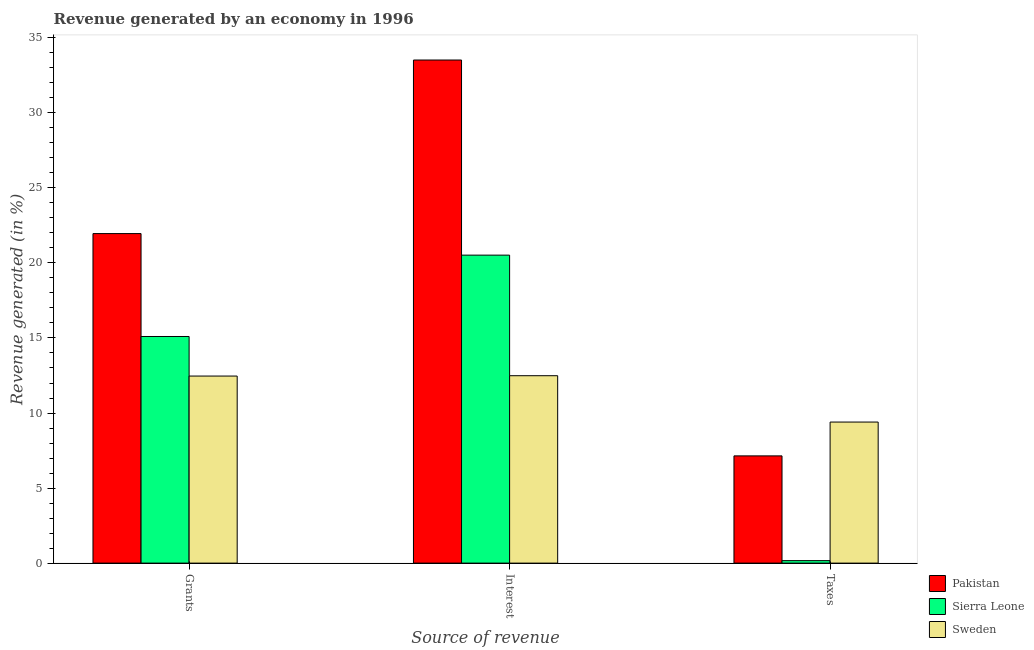How many groups of bars are there?
Your answer should be compact. 3. Are the number of bars on each tick of the X-axis equal?
Offer a very short reply. Yes. How many bars are there on the 1st tick from the left?
Your response must be concise. 3. How many bars are there on the 3rd tick from the right?
Keep it short and to the point. 3. What is the label of the 3rd group of bars from the left?
Your answer should be very brief. Taxes. What is the percentage of revenue generated by interest in Pakistan?
Keep it short and to the point. 33.52. Across all countries, what is the maximum percentage of revenue generated by interest?
Give a very brief answer. 33.52. Across all countries, what is the minimum percentage of revenue generated by interest?
Provide a short and direct response. 12.49. In which country was the percentage of revenue generated by interest minimum?
Your answer should be compact. Sweden. What is the total percentage of revenue generated by grants in the graph?
Your answer should be compact. 49.52. What is the difference between the percentage of revenue generated by grants in Sweden and that in Pakistan?
Your answer should be very brief. -9.49. What is the difference between the percentage of revenue generated by taxes in Sierra Leone and the percentage of revenue generated by interest in Sweden?
Your answer should be very brief. -12.32. What is the average percentage of revenue generated by taxes per country?
Your answer should be very brief. 5.57. What is the difference between the percentage of revenue generated by interest and percentage of revenue generated by grants in Pakistan?
Give a very brief answer. 11.56. In how many countries, is the percentage of revenue generated by taxes greater than 34 %?
Your answer should be very brief. 0. What is the ratio of the percentage of revenue generated by interest in Sierra Leone to that in Pakistan?
Provide a succinct answer. 0.61. What is the difference between the highest and the second highest percentage of revenue generated by taxes?
Make the answer very short. 2.25. What is the difference between the highest and the lowest percentage of revenue generated by interest?
Provide a succinct answer. 21.03. In how many countries, is the percentage of revenue generated by grants greater than the average percentage of revenue generated by grants taken over all countries?
Offer a terse response. 1. Is the sum of the percentage of revenue generated by interest in Sweden and Pakistan greater than the maximum percentage of revenue generated by taxes across all countries?
Give a very brief answer. Yes. What does the 1st bar from the left in Taxes represents?
Provide a succinct answer. Pakistan. Is it the case that in every country, the sum of the percentage of revenue generated by grants and percentage of revenue generated by interest is greater than the percentage of revenue generated by taxes?
Offer a terse response. Yes. How many bars are there?
Make the answer very short. 9. Are all the bars in the graph horizontal?
Your response must be concise. No. How many countries are there in the graph?
Provide a succinct answer. 3. How many legend labels are there?
Offer a very short reply. 3. How are the legend labels stacked?
Provide a short and direct response. Vertical. What is the title of the graph?
Provide a short and direct response. Revenue generated by an economy in 1996. What is the label or title of the X-axis?
Offer a terse response. Source of revenue. What is the label or title of the Y-axis?
Provide a succinct answer. Revenue generated (in %). What is the Revenue generated (in %) in Pakistan in Grants?
Your response must be concise. 21.96. What is the Revenue generated (in %) of Sierra Leone in Grants?
Offer a very short reply. 15.1. What is the Revenue generated (in %) in Sweden in Grants?
Your response must be concise. 12.46. What is the Revenue generated (in %) of Pakistan in Interest?
Offer a terse response. 33.52. What is the Revenue generated (in %) of Sierra Leone in Interest?
Provide a succinct answer. 20.52. What is the Revenue generated (in %) of Sweden in Interest?
Your response must be concise. 12.49. What is the Revenue generated (in %) in Pakistan in Taxes?
Offer a terse response. 7.14. What is the Revenue generated (in %) of Sierra Leone in Taxes?
Provide a succinct answer. 0.16. What is the Revenue generated (in %) in Sweden in Taxes?
Ensure brevity in your answer.  9.4. Across all Source of revenue, what is the maximum Revenue generated (in %) of Pakistan?
Provide a succinct answer. 33.52. Across all Source of revenue, what is the maximum Revenue generated (in %) in Sierra Leone?
Offer a terse response. 20.52. Across all Source of revenue, what is the maximum Revenue generated (in %) of Sweden?
Provide a succinct answer. 12.49. Across all Source of revenue, what is the minimum Revenue generated (in %) of Pakistan?
Keep it short and to the point. 7.14. Across all Source of revenue, what is the minimum Revenue generated (in %) in Sierra Leone?
Give a very brief answer. 0.16. Across all Source of revenue, what is the minimum Revenue generated (in %) of Sweden?
Offer a very short reply. 9.4. What is the total Revenue generated (in %) in Pakistan in the graph?
Your response must be concise. 62.62. What is the total Revenue generated (in %) in Sierra Leone in the graph?
Keep it short and to the point. 35.78. What is the total Revenue generated (in %) of Sweden in the graph?
Ensure brevity in your answer.  34.35. What is the difference between the Revenue generated (in %) in Pakistan in Grants and that in Interest?
Provide a succinct answer. -11.56. What is the difference between the Revenue generated (in %) of Sierra Leone in Grants and that in Interest?
Offer a very short reply. -5.42. What is the difference between the Revenue generated (in %) of Sweden in Grants and that in Interest?
Give a very brief answer. -0.02. What is the difference between the Revenue generated (in %) in Pakistan in Grants and that in Taxes?
Offer a terse response. 14.81. What is the difference between the Revenue generated (in %) in Sierra Leone in Grants and that in Taxes?
Offer a terse response. 14.93. What is the difference between the Revenue generated (in %) in Sweden in Grants and that in Taxes?
Ensure brevity in your answer.  3.06. What is the difference between the Revenue generated (in %) in Pakistan in Interest and that in Taxes?
Make the answer very short. 26.37. What is the difference between the Revenue generated (in %) in Sierra Leone in Interest and that in Taxes?
Your response must be concise. 20.35. What is the difference between the Revenue generated (in %) in Sweden in Interest and that in Taxes?
Your answer should be very brief. 3.09. What is the difference between the Revenue generated (in %) of Pakistan in Grants and the Revenue generated (in %) of Sierra Leone in Interest?
Give a very brief answer. 1.44. What is the difference between the Revenue generated (in %) in Pakistan in Grants and the Revenue generated (in %) in Sweden in Interest?
Make the answer very short. 9.47. What is the difference between the Revenue generated (in %) in Sierra Leone in Grants and the Revenue generated (in %) in Sweden in Interest?
Your answer should be very brief. 2.61. What is the difference between the Revenue generated (in %) of Pakistan in Grants and the Revenue generated (in %) of Sierra Leone in Taxes?
Offer a very short reply. 21.79. What is the difference between the Revenue generated (in %) in Pakistan in Grants and the Revenue generated (in %) in Sweden in Taxes?
Your answer should be compact. 12.56. What is the difference between the Revenue generated (in %) of Sierra Leone in Grants and the Revenue generated (in %) of Sweden in Taxes?
Offer a terse response. 5.7. What is the difference between the Revenue generated (in %) in Pakistan in Interest and the Revenue generated (in %) in Sierra Leone in Taxes?
Provide a succinct answer. 33.35. What is the difference between the Revenue generated (in %) of Pakistan in Interest and the Revenue generated (in %) of Sweden in Taxes?
Provide a succinct answer. 24.12. What is the difference between the Revenue generated (in %) in Sierra Leone in Interest and the Revenue generated (in %) in Sweden in Taxes?
Your answer should be very brief. 11.12. What is the average Revenue generated (in %) in Pakistan per Source of revenue?
Offer a very short reply. 20.87. What is the average Revenue generated (in %) in Sierra Leone per Source of revenue?
Make the answer very short. 11.93. What is the average Revenue generated (in %) of Sweden per Source of revenue?
Ensure brevity in your answer.  11.45. What is the difference between the Revenue generated (in %) of Pakistan and Revenue generated (in %) of Sierra Leone in Grants?
Keep it short and to the point. 6.86. What is the difference between the Revenue generated (in %) in Pakistan and Revenue generated (in %) in Sweden in Grants?
Provide a succinct answer. 9.49. What is the difference between the Revenue generated (in %) of Sierra Leone and Revenue generated (in %) of Sweden in Grants?
Keep it short and to the point. 2.64. What is the difference between the Revenue generated (in %) in Pakistan and Revenue generated (in %) in Sierra Leone in Interest?
Make the answer very short. 13. What is the difference between the Revenue generated (in %) of Pakistan and Revenue generated (in %) of Sweden in Interest?
Give a very brief answer. 21.03. What is the difference between the Revenue generated (in %) in Sierra Leone and Revenue generated (in %) in Sweden in Interest?
Offer a very short reply. 8.03. What is the difference between the Revenue generated (in %) of Pakistan and Revenue generated (in %) of Sierra Leone in Taxes?
Make the answer very short. 6.98. What is the difference between the Revenue generated (in %) in Pakistan and Revenue generated (in %) in Sweden in Taxes?
Ensure brevity in your answer.  -2.25. What is the difference between the Revenue generated (in %) in Sierra Leone and Revenue generated (in %) in Sweden in Taxes?
Give a very brief answer. -9.23. What is the ratio of the Revenue generated (in %) in Pakistan in Grants to that in Interest?
Keep it short and to the point. 0.66. What is the ratio of the Revenue generated (in %) of Sierra Leone in Grants to that in Interest?
Provide a succinct answer. 0.74. What is the ratio of the Revenue generated (in %) in Pakistan in Grants to that in Taxes?
Your response must be concise. 3.07. What is the ratio of the Revenue generated (in %) of Sierra Leone in Grants to that in Taxes?
Ensure brevity in your answer.  91.58. What is the ratio of the Revenue generated (in %) in Sweden in Grants to that in Taxes?
Your answer should be compact. 1.33. What is the ratio of the Revenue generated (in %) of Pakistan in Interest to that in Taxes?
Keep it short and to the point. 4.69. What is the ratio of the Revenue generated (in %) in Sierra Leone in Interest to that in Taxes?
Give a very brief answer. 124.46. What is the ratio of the Revenue generated (in %) of Sweden in Interest to that in Taxes?
Provide a short and direct response. 1.33. What is the difference between the highest and the second highest Revenue generated (in %) in Pakistan?
Keep it short and to the point. 11.56. What is the difference between the highest and the second highest Revenue generated (in %) in Sierra Leone?
Offer a very short reply. 5.42. What is the difference between the highest and the second highest Revenue generated (in %) of Sweden?
Your answer should be compact. 0.02. What is the difference between the highest and the lowest Revenue generated (in %) of Pakistan?
Give a very brief answer. 26.37. What is the difference between the highest and the lowest Revenue generated (in %) of Sierra Leone?
Offer a very short reply. 20.35. What is the difference between the highest and the lowest Revenue generated (in %) of Sweden?
Offer a very short reply. 3.09. 